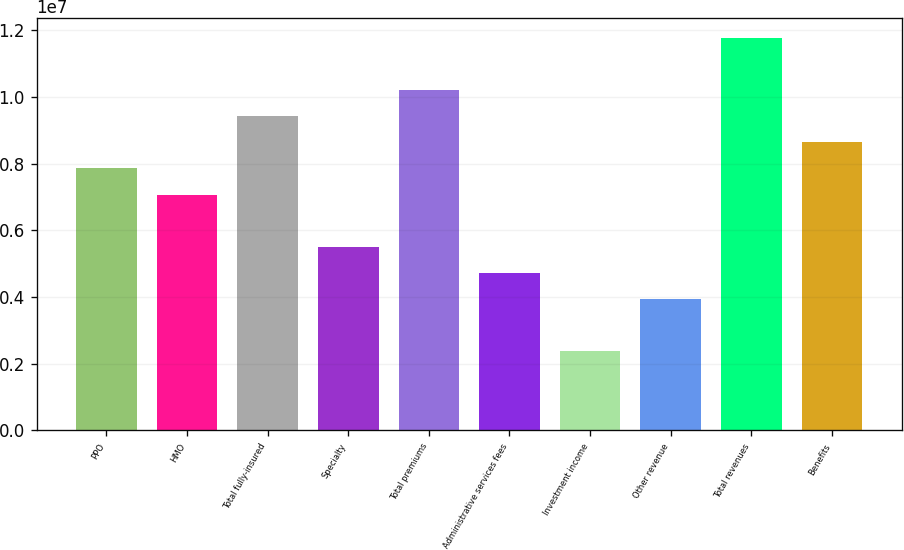<chart> <loc_0><loc_0><loc_500><loc_500><bar_chart><fcel>PPO<fcel>HMO<fcel>Total fully-insured<fcel>Specialty<fcel>Total premiums<fcel>Administrative services fees<fcel>Investment income<fcel>Other revenue<fcel>Total revenues<fcel>Benefits<nl><fcel>7.85547e+06<fcel>7.07361e+06<fcel>9.4192e+06<fcel>5.50988e+06<fcel>1.02011e+07<fcel>4.72801e+06<fcel>2.38242e+06<fcel>3.94615e+06<fcel>1.17648e+07<fcel>8.63733e+06<nl></chart> 